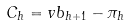Convert formula to latex. <formula><loc_0><loc_0><loc_500><loc_500>C _ { h } = v b _ { h + 1 } - \pi _ { h }</formula> 